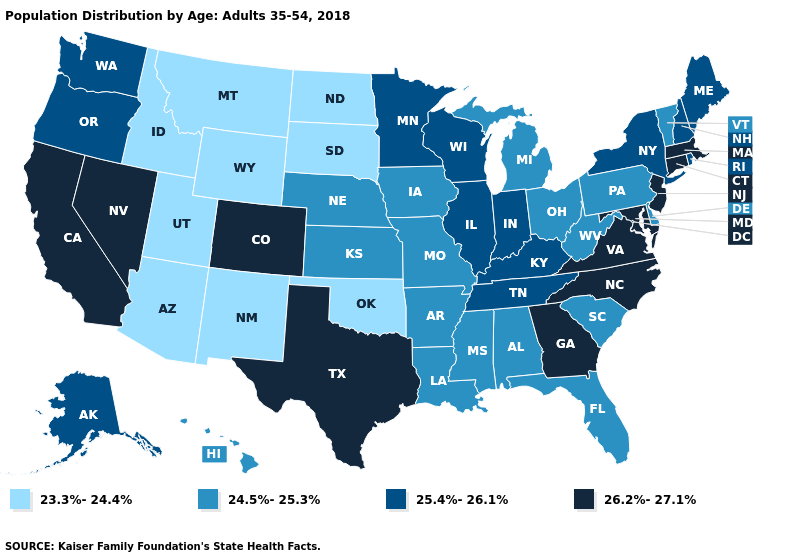What is the value of Vermont?
Concise answer only. 24.5%-25.3%. Name the states that have a value in the range 24.5%-25.3%?
Keep it brief. Alabama, Arkansas, Delaware, Florida, Hawaii, Iowa, Kansas, Louisiana, Michigan, Mississippi, Missouri, Nebraska, Ohio, Pennsylvania, South Carolina, Vermont, West Virginia. What is the value of Connecticut?
Quick response, please. 26.2%-27.1%. Which states have the lowest value in the USA?
Keep it brief. Arizona, Idaho, Montana, New Mexico, North Dakota, Oklahoma, South Dakota, Utah, Wyoming. Does Rhode Island have a higher value than Massachusetts?
Write a very short answer. No. Name the states that have a value in the range 23.3%-24.4%?
Quick response, please. Arizona, Idaho, Montana, New Mexico, North Dakota, Oklahoma, South Dakota, Utah, Wyoming. Does Indiana have a lower value than Colorado?
Concise answer only. Yes. Among the states that border North Dakota , which have the highest value?
Concise answer only. Minnesota. Name the states that have a value in the range 24.5%-25.3%?
Be succinct. Alabama, Arkansas, Delaware, Florida, Hawaii, Iowa, Kansas, Louisiana, Michigan, Mississippi, Missouri, Nebraska, Ohio, Pennsylvania, South Carolina, Vermont, West Virginia. Does Nevada have the same value as Maryland?
Keep it brief. Yes. Name the states that have a value in the range 24.5%-25.3%?
Quick response, please. Alabama, Arkansas, Delaware, Florida, Hawaii, Iowa, Kansas, Louisiana, Michigan, Mississippi, Missouri, Nebraska, Ohio, Pennsylvania, South Carolina, Vermont, West Virginia. Which states have the lowest value in the USA?
Quick response, please. Arizona, Idaho, Montana, New Mexico, North Dakota, Oklahoma, South Dakota, Utah, Wyoming. Name the states that have a value in the range 24.5%-25.3%?
Short answer required. Alabama, Arkansas, Delaware, Florida, Hawaii, Iowa, Kansas, Louisiana, Michigan, Mississippi, Missouri, Nebraska, Ohio, Pennsylvania, South Carolina, Vermont, West Virginia. Name the states that have a value in the range 25.4%-26.1%?
Short answer required. Alaska, Illinois, Indiana, Kentucky, Maine, Minnesota, New Hampshire, New York, Oregon, Rhode Island, Tennessee, Washington, Wisconsin. What is the highest value in the Northeast ?
Quick response, please. 26.2%-27.1%. 